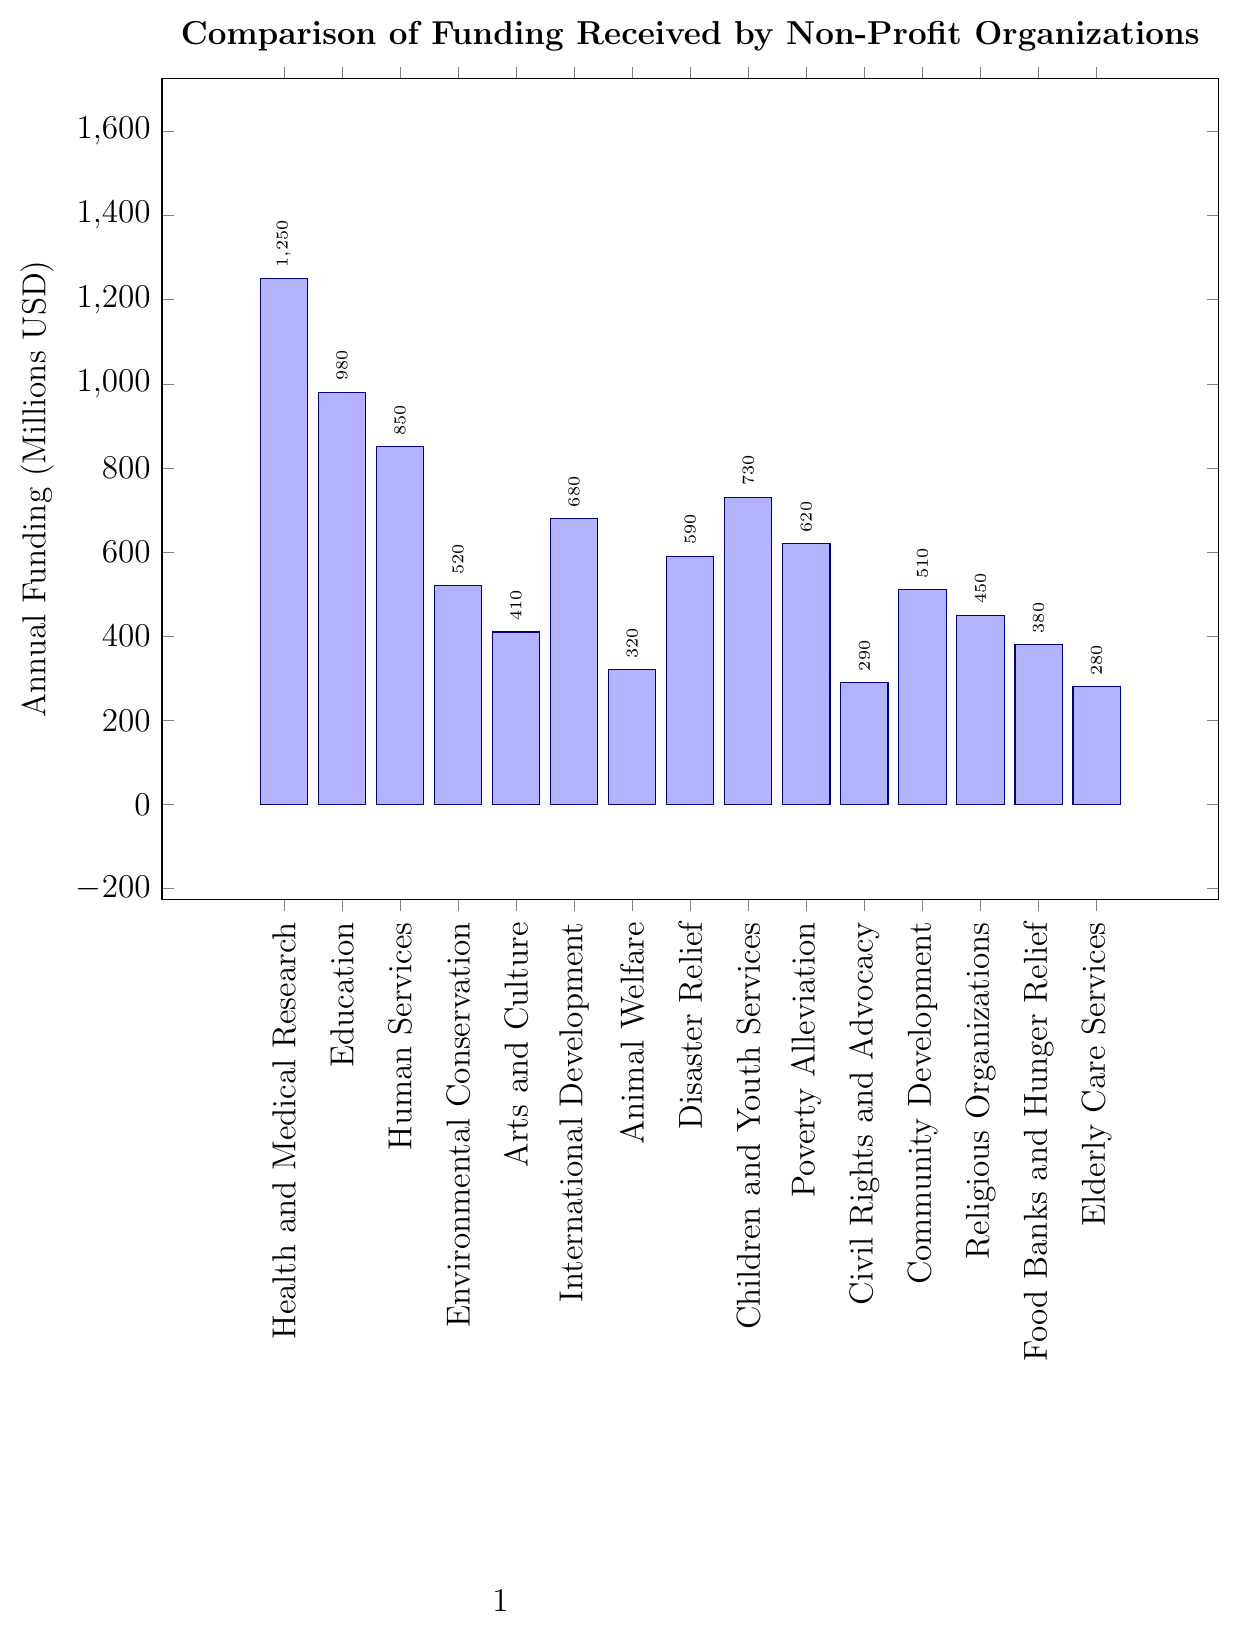What's the highest amount of funding received by any organization type? The tallest bar indicates the highest amount of funding. The bar for "Health and Medical Research" reaches the highest point at $1250 million.
Answer: Health and Medical Research Which two organization types receive less funding than Animal Welfare? From the height of the bars, we see "Civil Rights and Advocacy" and "Elderly Care Services" bars are shorter than the "Animal Welfare" bar. Their funding amounts are less than Animal Welfare's $320 million.
Answer: Civil Rights and Advocacy and Elderly Care Services What is the difference in funding between Education and Disaster Relief organizations? The bar for "Education" shows $980 million, and the bar for "Disaster Relief" shows $590 million. Subtracting these two values, we get $980 - $590 = $390 million.
Answer: $390 million Order the following organization types by their funding from highest to lowest: International Development, Community Development, and Food Banks and Hunger Relief Checking the heights of the respective bars: "International Development" ($680 million), "Community Development" ($510 million), and "Food Banks and Hunger Relief" ($380 million). Ordering from highest to lowest gives us: "International Development", "Community Development", and "Food Banks and Hunger Relief".
Answer: International Development, Community Development, Food Banks and Hunger Relief What is the average funding received by Human Services, Education, and Environmental Conservation organizations? The funding amounts are: Human Services ($850 million), Education ($980 million), and Environmental Conservation ($520 million). The total is $850 + $980 + $520 = $2350 million. There are 3 organizations, so the average is $2350 / 3 = approximately $783.33 million.
Answer: Approximately $783.33 million Which organization type receives exactly $410 million in funding, and what is its relative position among all bars? The bar for "Arts and Culture" reaches the $410 million mark. Visually, it is positioned as the fifth bar when counting from the largest funding to smallest.
Answer: Arts and Culture, fifth position If combined, do the funding amounts for Animal Welfare and Elderly Care Services exceed that for Poverty Alleviation? Animal Welfare has $320 million, and Elderly Care Services has $280 million. Combined, this is $320 + $280 = $600 million. Poverty Alleviation has $620 million. So, the combined funding is less.
Answer: No Which organization type's funding is closest to the median funding level of all organization types? Ordering the funding amounts: $1250, $980, $850, $730, $680, $620, $590, $520, $510, $450, $410, $380, $320, $290, $280 million, the median value is the 8th value ($520 million). The closest funding to this is "Environmental Conservation" with $520 million.
Answer: Environmental Conservation How much more funding does Children and Youth Services receive compared to Religious Organizations? Children and Youth Services has $730 million and Religious Organizations have $450 million. The difference is $730 - $450 = $280 million.
Answer: $280 million What is the total funding received by Civil Rights and Advocacy, Community Development, and Food Banks and Hunger Relief combined? The funding amounts are $290 million, $510 million, and $380 million respectively. Summing them up, $290 + $510 + $380 = $1180 million.
Answer: $1180 million 